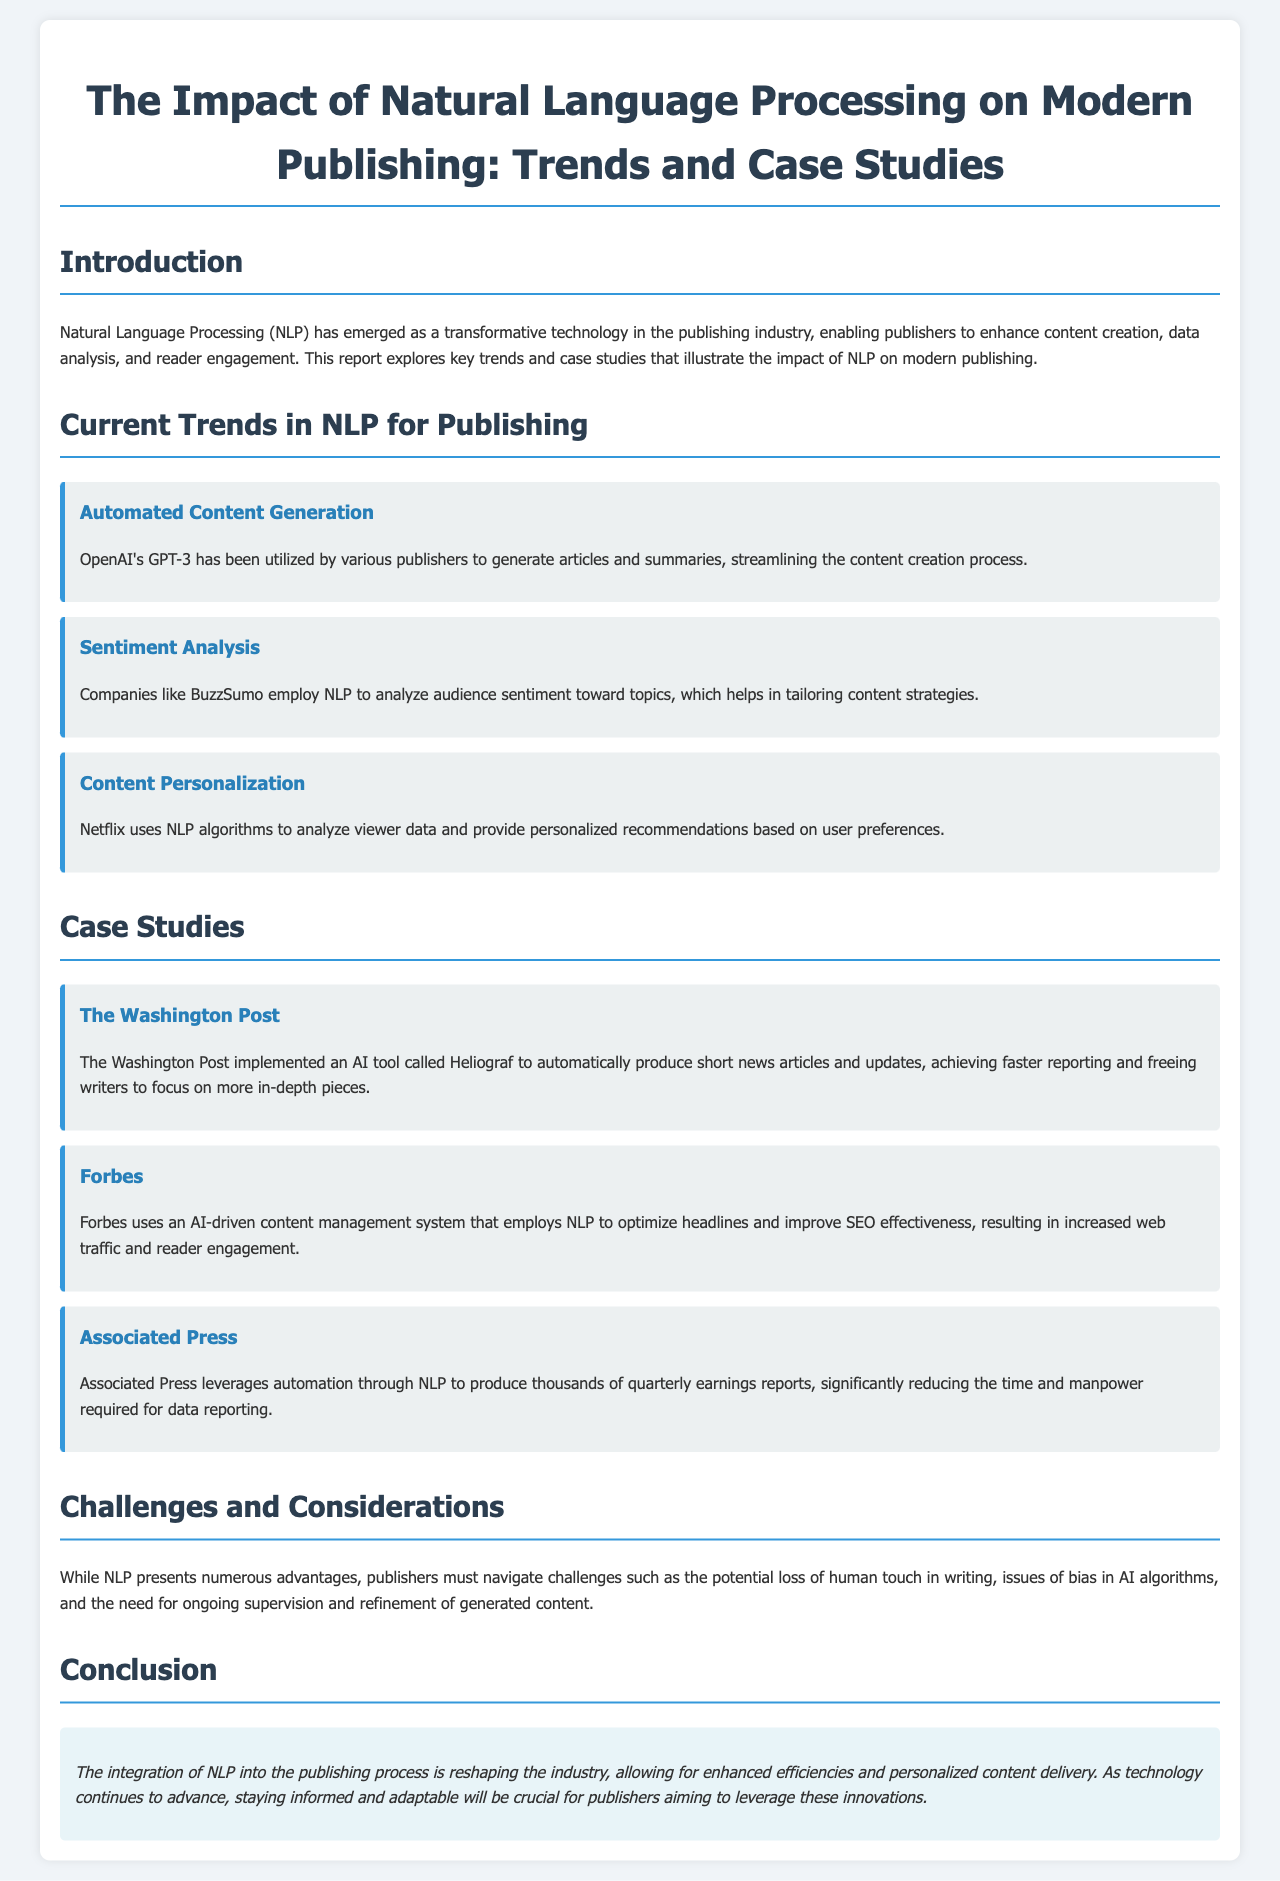What is the main technology discussed in the report? The report discusses Natural Language Processing (NLP) as a transformative technology in the publishing industry.
Answer: Natural Language Processing (NLP) Which company utilizes GPT-3 for content generation? OpenAI's GPT-3 is mentioned as being utilized by various publishers for automated content generation.
Answer: OpenAI What is the name of the AI tool used by The Washington Post? The Washington Post implemented an AI tool called Heliograf to produce news articles.
Answer: Heliograf What advantage does Forbes' AI-driven system provide? Forbes uses an AI-driven content management system that optimizes headlines and improves SEO effectiveness.
Answer: SEO effectiveness What is a challenge mentioned regarding NLP in publishing? The report notes the potential loss of human touch in writing as a challenge with NLP.
Answer: Loss of human touch What type of analysis does BuzzSumo employ? BuzzSumo employs sentiment analysis to understand audience sentiment toward topics.
Answer: Sentiment analysis How does Netflix utilize NLP? Netflix uses NLP algorithms to analyze viewer data for providing recommendations.
Answer: Recommendations Which organization produces quarterly earnings reports with NLP automation? Associated Press leverages automation through NLP to produce quarterly earnings reports.
Answer: Associated Press What is the conclusion about the integration of NLP? The conclusion states that the integration of NLP is reshaping the industry and enhancing efficiencies.
Answer: Reshaping the industry 